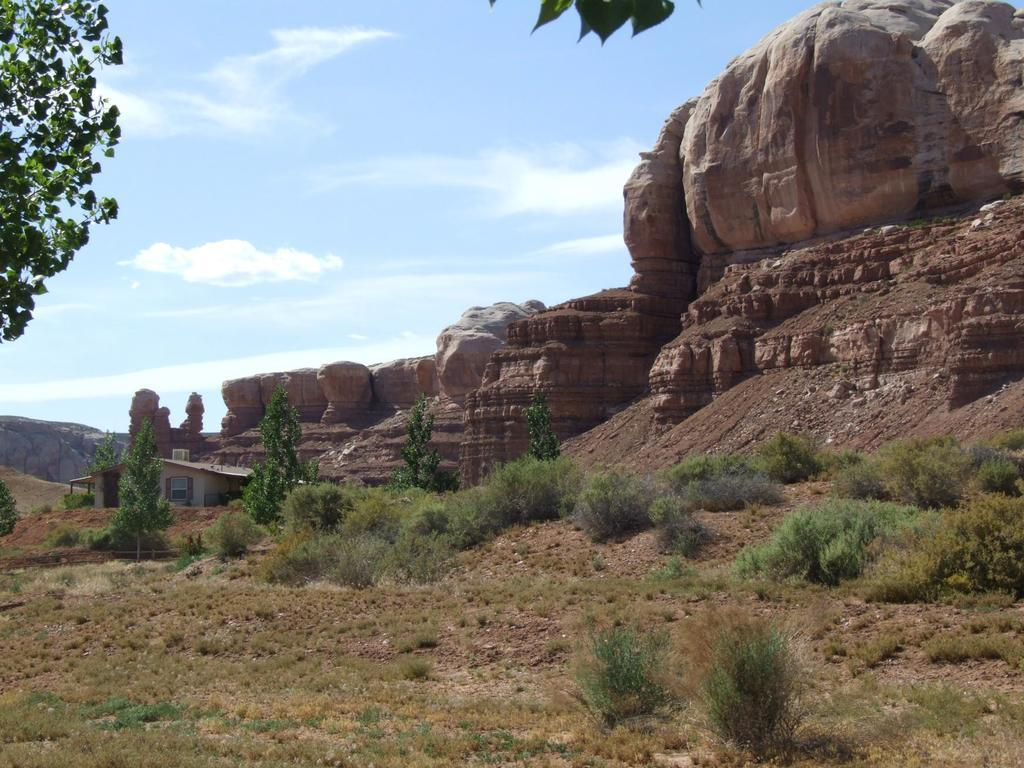What type of vegetation can be seen in the image? There are trees and plants in the image. What type of landscape feature is present in the image? There are hills in the image. What type of structure can be seen in the image? There is a house in the image. What is visible in the sky in the image? There are clouds visible in the sky, and the sky itself is visible in the image. Where is the sugar stored in the image? There is no mention of sugar or any storage for it in the image. What type of market can be seen in the image? There is no market present in the image; it features trees, plants, hills, a house, clouds, and the sky. 